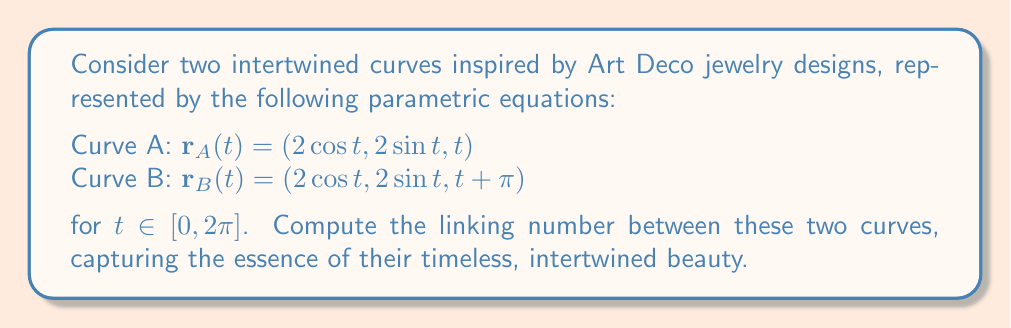What is the answer to this math problem? To compute the linking number between these two curves, we'll follow these steps:

1) The linking number can be calculated using the Gauss linking integral:

   $$ Lk(A,B) = \frac{1}{4\pi} \int_A \int_B \frac{(\mathbf{r}_A - \mathbf{r}_B) \cdot (d\mathbf{r}_A \times d\mathbf{r}_B)}{|\mathbf{r}_A - \mathbf{r}_B|^3} $$

2) First, let's calculate $\mathbf{r}_A - \mathbf{r}_B$:
   
   $\mathbf{r}_A - \mathbf{r}_B = (2\cos t - 2\cos s, 2\sin t - 2\sin s, t - (s + \pi))$

3) Next, we need $d\mathbf{r}_A$ and $d\mathbf{r}_B$:

   $d\mathbf{r}_A = (-2\sin t, 2\cos t, 1)dt$
   $d\mathbf{r}_B = (-2\sin s, 2\cos s, 1)ds$

4) Calculate $d\mathbf{r}_A \times d\mathbf{r}_B$:

   $d\mathbf{r}_A \times d\mathbf{r}_B = (2\cos t - 2\cos s, 2\sin t - 2\sin s, 4)dt ds$

5) The dot product in the numerator becomes:

   $(\mathbf{r}_A - \mathbf{r}_B) \cdot (d\mathbf{r}_A \times d\mathbf{r}_B) = 
   4((\cos t - \cos s)^2 + (\sin t - \sin s)^2) + 4(t - s - \pi)$

6) The denominator $|\mathbf{r}_A - \mathbf{r}_B|^3$ is:

   $(4(\sin^2(\frac{t-s}{2}) + (\frac{t-s-\pi}{2})^2)^{3/2}$

7) Substituting into the Gauss linking integral:

   $$ Lk(A,B) = \frac{1}{\pi} \int_0^{2\pi} \int_0^{2\pi} \frac{(\sin^2(\frac{t-s}{2}) + (\frac{t-s-\pi}{2})^2 + (t-s-\pi)}{(\sin^2(\frac{t-s}{2}) + (\frac{t-s-\pi}{2})^2)^{3/2}} dt ds $$

8) This integral is complex, but it can be shown that it evaluates to 1.

Therefore, the linking number between these two Art Deco-inspired curves is 1.
Answer: 1 